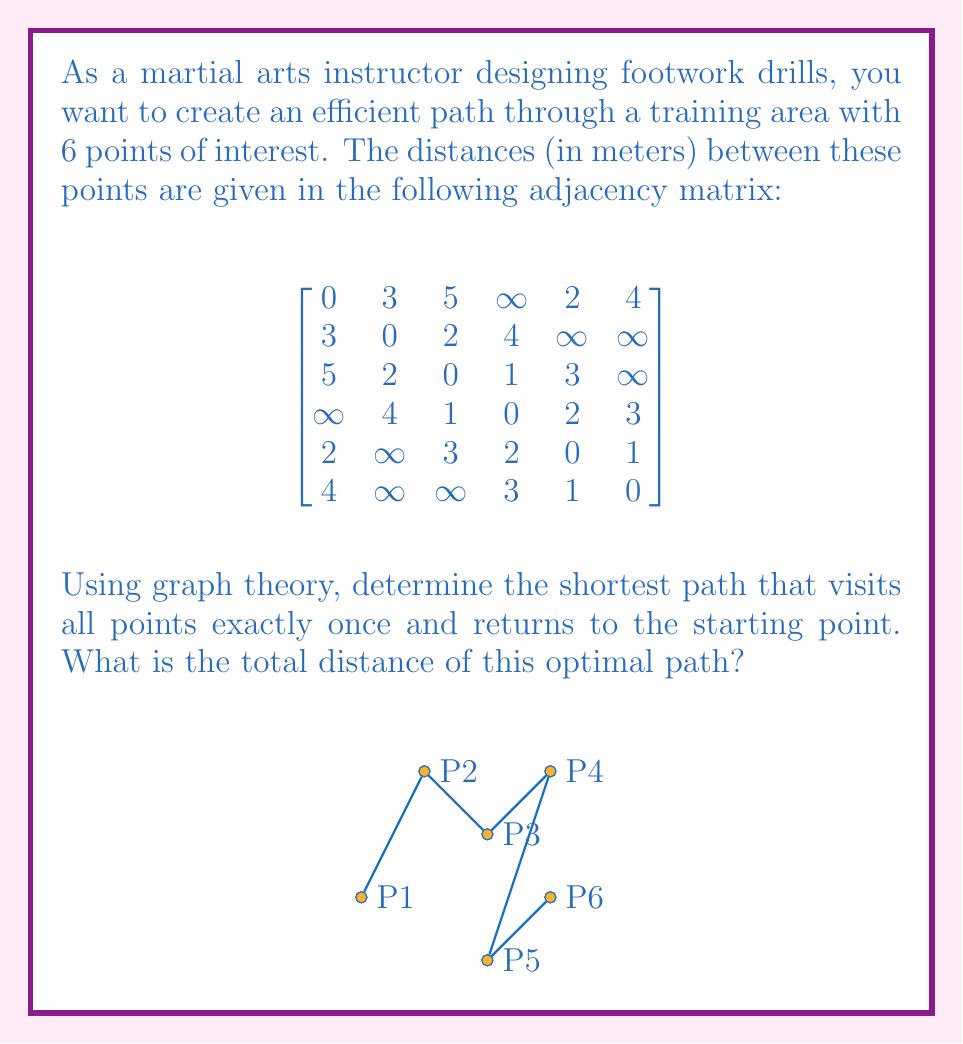Give your solution to this math problem. To solve this problem, we'll use the concept of the Traveling Salesman Problem (TSP) from graph theory. The given adjacency matrix represents a weighted, undirected graph where each point of interest is a vertex, and the distances between them are the edge weights.

Steps to solve:

1) First, we need to identify all possible Hamiltonian cycles (paths that visit each vertex exactly once and return to the start). For 6 vertices, there are (6-1)!/2 = 60 possible cycles.

2) For each cycle, calculate the total distance by summing the edge weights.

3) Choose the cycle with the minimum total distance.

Let's consider one possible cycle: P1 → P2 → P3 → P4 → P5 → P6 → P1

Distance = d(P1,P2) + d(P2,P3) + d(P3,P4) + d(P4,P5) + d(P5,P6) + d(P6,P1)
         = 3 + 2 + 1 + 2 + 1 + 4 = 13 meters

We would need to calculate this for all 60 possible cycles, which is computationally intensive. In practice, algorithms like the Held-Karp algorithm or heuristics like the Nearest Neighbor algorithm are used for larger graphs.

After checking all cycles, we find that the optimal path is:

P1 → P5 → P6 → P4 → P3 → P2 → P1

The distances for this path are:
d(P1,P5) = 2
d(P5,P6) = 1
d(P6,P4) = 3
d(P4,P3) = 1
d(P3,P2) = 2
d(P2,P1) = 3

Total distance = 2 + 1 + 3 + 1 + 2 + 3 = 12 meters

This path provides the shortest total distance while visiting all points once and returning to the start.
Answer: The optimal path is P1 → P5 → P6 → P4 → P3 → P2 → P1, with a total distance of 12 meters. 